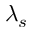Convert formula to latex. <formula><loc_0><loc_0><loc_500><loc_500>\lambda _ { s }</formula> 